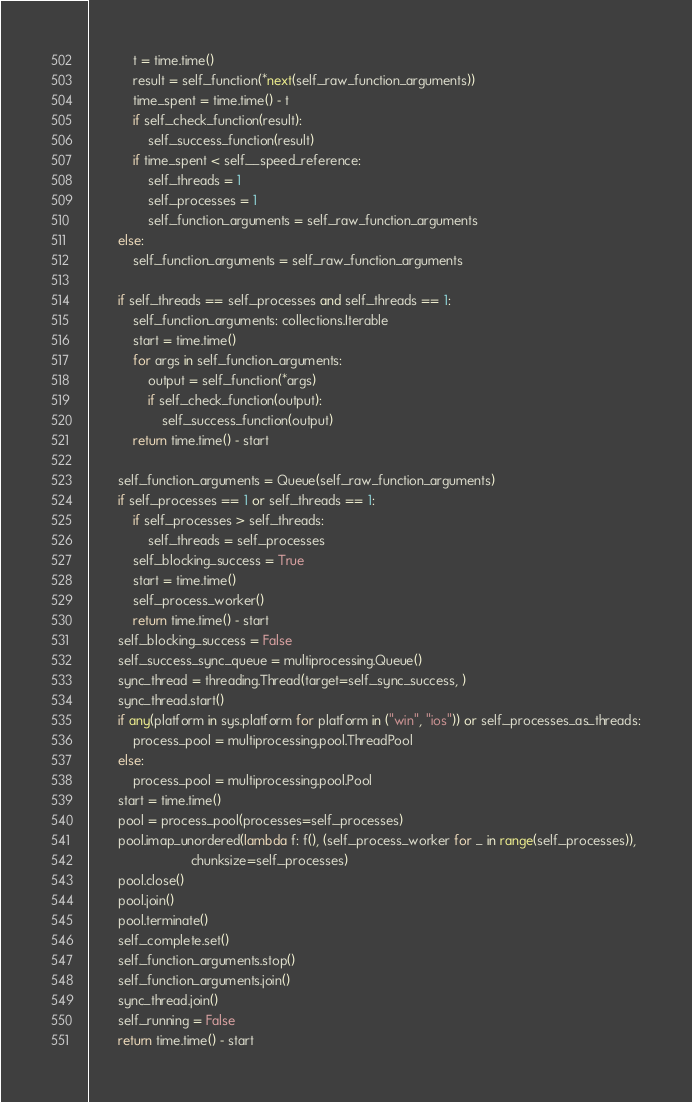<code> <loc_0><loc_0><loc_500><loc_500><_Python_>			t = time.time()
			result = self._function(*next(self._raw_function_arguments))
			time_spent = time.time() - t
			if self._check_function(result):
				self._success_function(result)
			if time_spent < self.__speed_reference:
				self._threads = 1
				self._processes = 1
				self._function_arguments = self._raw_function_arguments
		else:
			self._function_arguments = self._raw_function_arguments

		if self._threads == self._processes and self._threads == 1:
			self._function_arguments: collections.Iterable
			start = time.time()
			for args in self._function_arguments:
				output = self._function(*args)
				if self._check_function(output):
					self._success_function(output)
			return time.time() - start

		self._function_arguments = Queue(self._raw_function_arguments)
		if self._processes == 1 or self._threads == 1:
			if self._processes > self._threads:
				self._threads = self._processes
			self._blocking_success = True
			start = time.time()
			self._process_worker()
			return time.time() - start
		self._blocking_success = False
		self._success_sync_queue = multiprocessing.Queue()
		sync_thread = threading.Thread(target=self._sync_success, )
		sync_thread.start()
		if any(platform in sys.platform for platform in ("win", "ios")) or self._processes_as_threads:
			process_pool = multiprocessing.pool.ThreadPool
		else:
			process_pool = multiprocessing.pool.Pool
		start = time.time()
		pool = process_pool(processes=self._processes)
		pool.imap_unordered(lambda f: f(), (self._process_worker for _ in range(self._processes)),
							chunksize=self._processes)
		pool.close()
		pool.join()
		pool.terminate()
		self._complete.set()
		self._function_arguments.stop()
		self._function_arguments.join()
		sync_thread.join()
		self._running = False
		return time.time() - start
</code> 